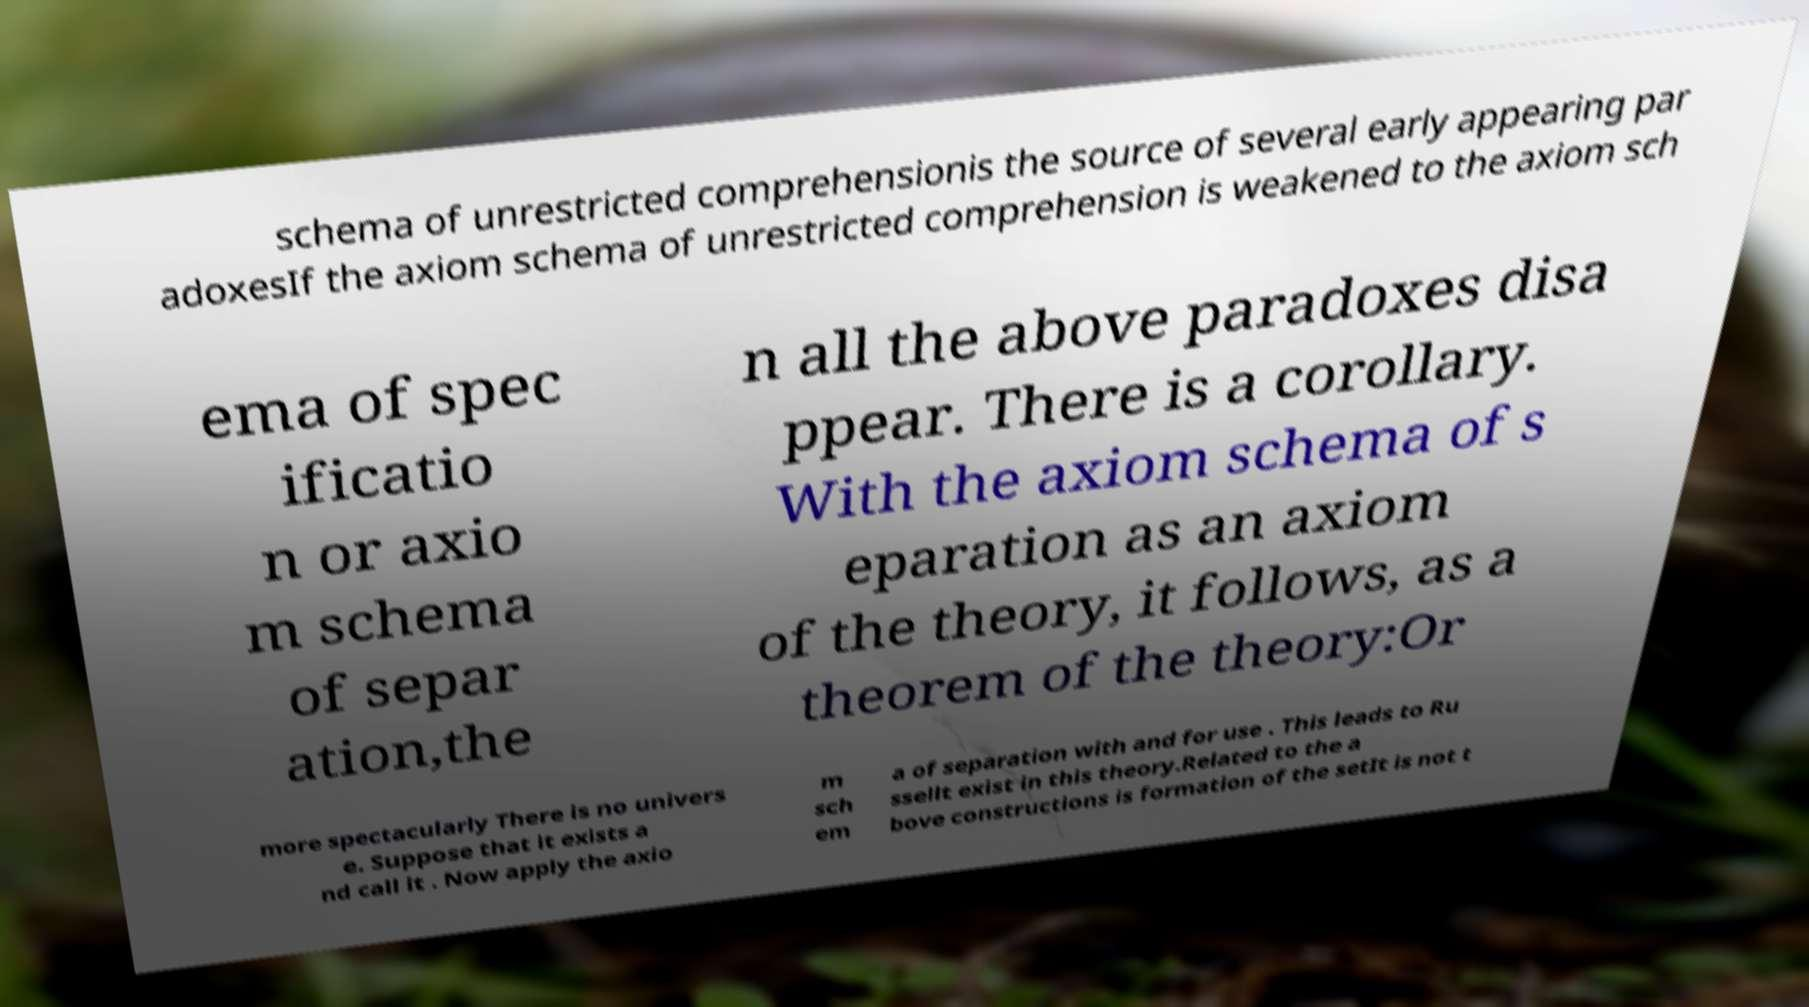There's text embedded in this image that I need extracted. Can you transcribe it verbatim? schema of unrestricted comprehensionis the source of several early appearing par adoxesIf the axiom schema of unrestricted comprehension is weakened to the axiom sch ema of spec ificatio n or axio m schema of separ ation,the n all the above paradoxes disa ppear. There is a corollary. With the axiom schema of s eparation as an axiom of the theory, it follows, as a theorem of the theory:Or more spectacularly There is no univers e. Suppose that it exists a nd call it . Now apply the axio m sch em a of separation with and for use . This leads to Ru ssellt exist in this theory.Related to the a bove constructions is formation of the setIt is not t 